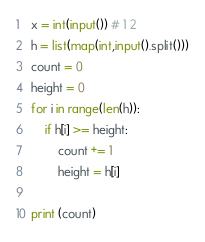<code> <loc_0><loc_0><loc_500><loc_500><_Python_>x = int(input()) # 1 2
h = list(map(int,input().split()))
count = 0
height = 0
for i in range(len(h)):
    if h[i] >= height:
        count += 1
        height = h[i]

print (count)
</code> 